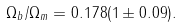Convert formula to latex. <formula><loc_0><loc_0><loc_500><loc_500>\Omega _ { b } / \Omega _ { m } = 0 . 1 7 8 ( 1 \pm 0 . 0 9 ) .</formula> 